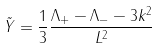Convert formula to latex. <formula><loc_0><loc_0><loc_500><loc_500>\tilde { Y } = \frac { 1 } { 3 } \frac { \Lambda _ { + } - \Lambda _ { - } - 3 k ^ { 2 } } { L ^ { 2 } }</formula> 